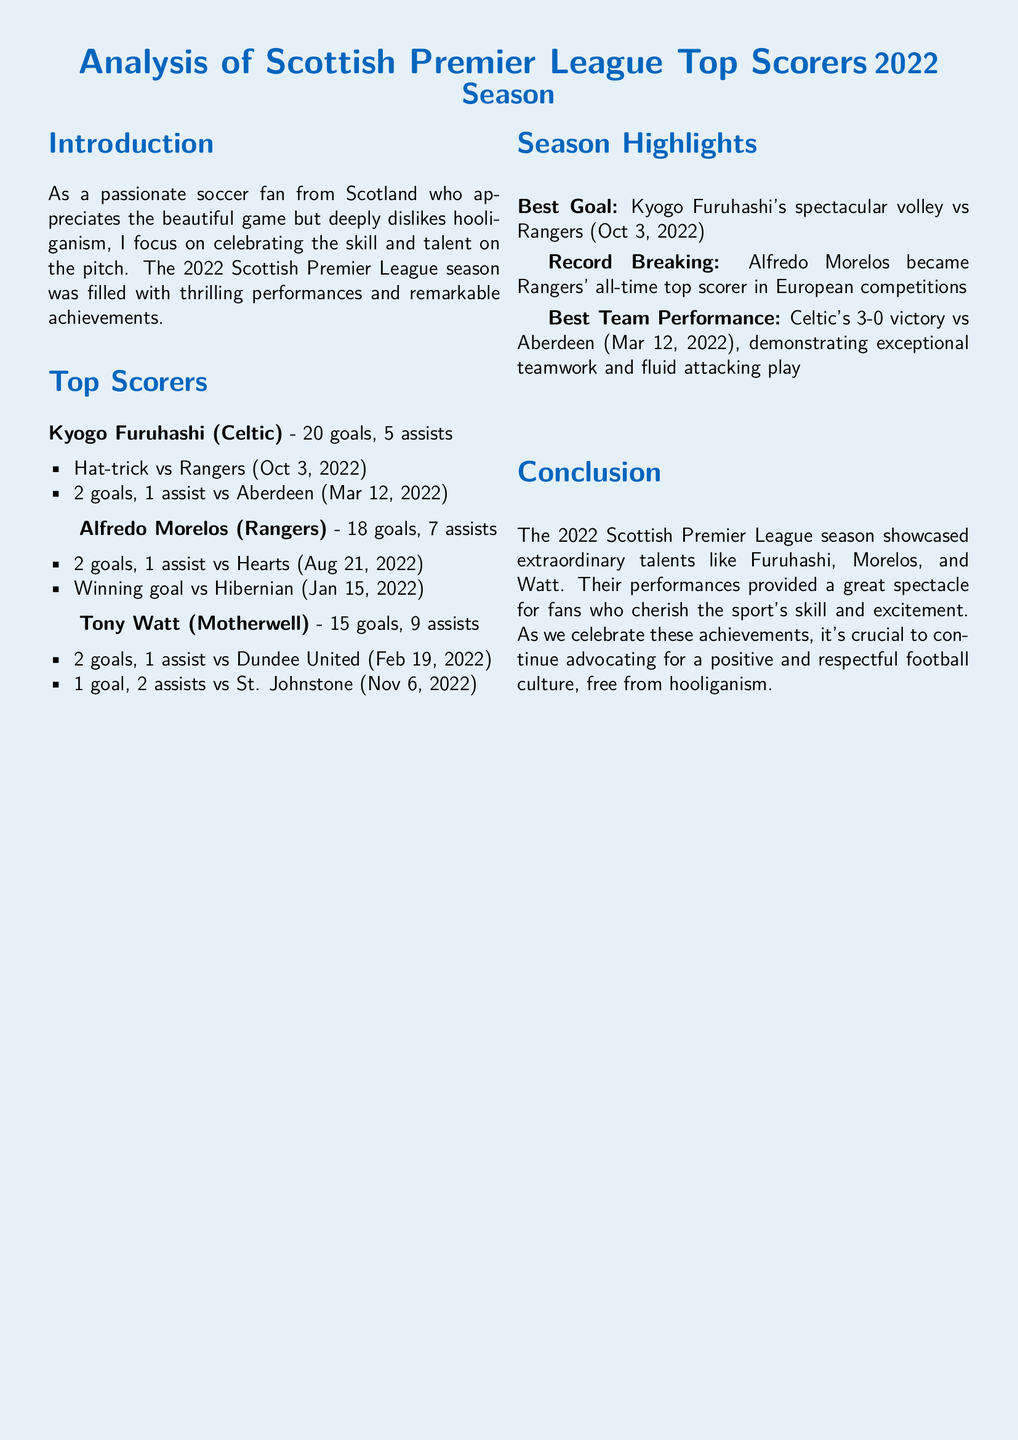What was Kyogo Furuhashi's total number of goals? The document states that Kyogo Furuhashi scored 20 goals, which is specifically listed under his statistics.
Answer: 20 goals Who is the all-time top scorer in European competitions for Rangers? The document mentions that Alfredo Morelos became Rangers' all-time top scorer in European competitions, providing this key detail about his achievement.
Answer: Alfredo Morelos How many assists did Tony Watt record during the season? Tony Watt's statistics include 9 assists, which is clearly indicated in his section of the document.
Answer: 9 assists What was the date of Kyogo Furuhashi's hat-trick against Rangers? The document lists the date of the hat-trick as October 3, 2022, which is provided in the details of his performance highlights.
Answer: October 3, 2022 Which team had the best performance in the season according to the document? The document states that Celtic's 3-0 victory vs Aberdeen is recognized as the best team performance of the season, making this distinction clear.
Answer: Celtic What is noted as the best goal of the season? The document identifies Kyogo Furuhashi's spectacular volley vs Rangers as the best goal, highlighting this specific moment.
Answer: Kyogo Furuhashi's spectacular volley vs Rangers How many goals did Alfredo Morelos score in the season? The total number of goals scored by Alfredo Morelos is given as 18, which is mentioned in the context of his statistics.
Answer: 18 goals What significant achievement did Alfredo Morelos reach during the 2022 season? The document notes that he became Rangers' all-time top scorer in European competitions, highlighting this important milestone.
Answer: Rangers' all-time top scorer in European competitions 